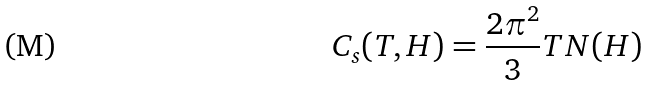Convert formula to latex. <formula><loc_0><loc_0><loc_500><loc_500>C _ { s } ( T , H ) = \frac { 2 \pi ^ { 2 } } { 3 } T N ( H )</formula> 